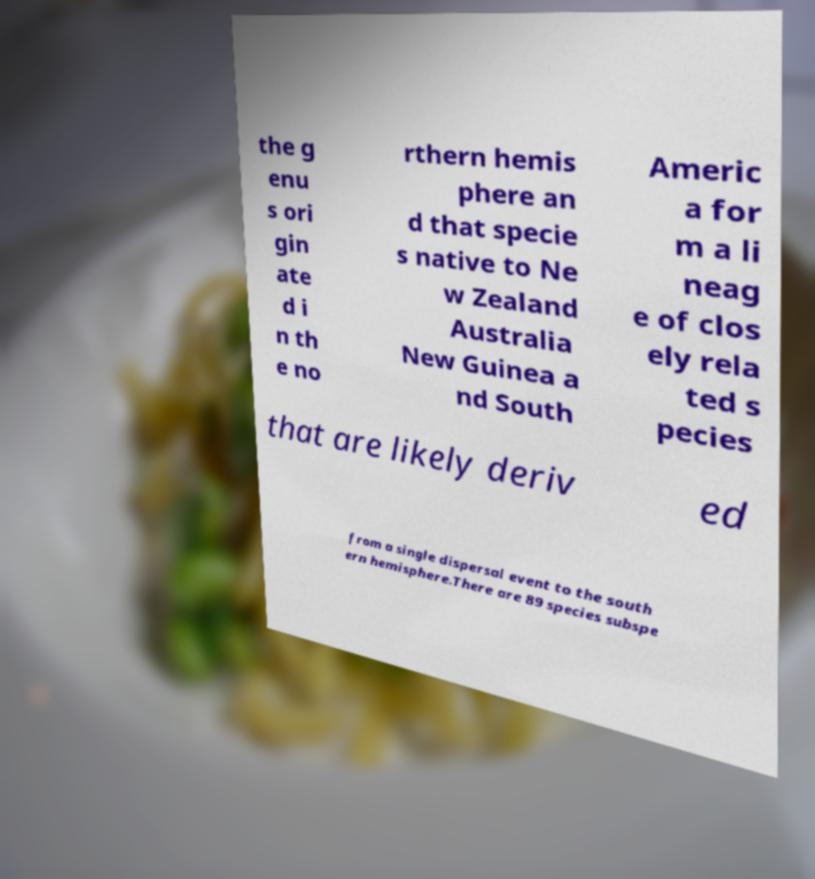Could you assist in decoding the text presented in this image and type it out clearly? the g enu s ori gin ate d i n th e no rthern hemis phere an d that specie s native to Ne w Zealand Australia New Guinea a nd South Americ a for m a li neag e of clos ely rela ted s pecies that are likely deriv ed from a single dispersal event to the south ern hemisphere.There are 89 species subspe 